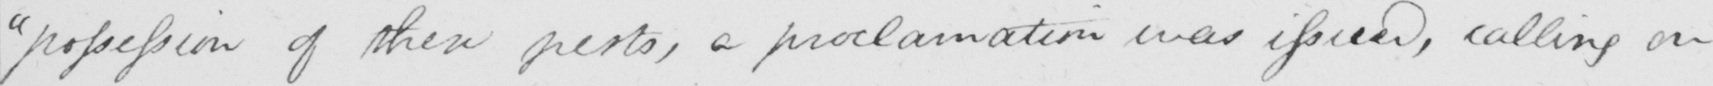What does this handwritten line say? "possession of these pests, a proclamation was issued, calling on 